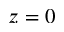<formula> <loc_0><loc_0><loc_500><loc_500>z = 0</formula> 